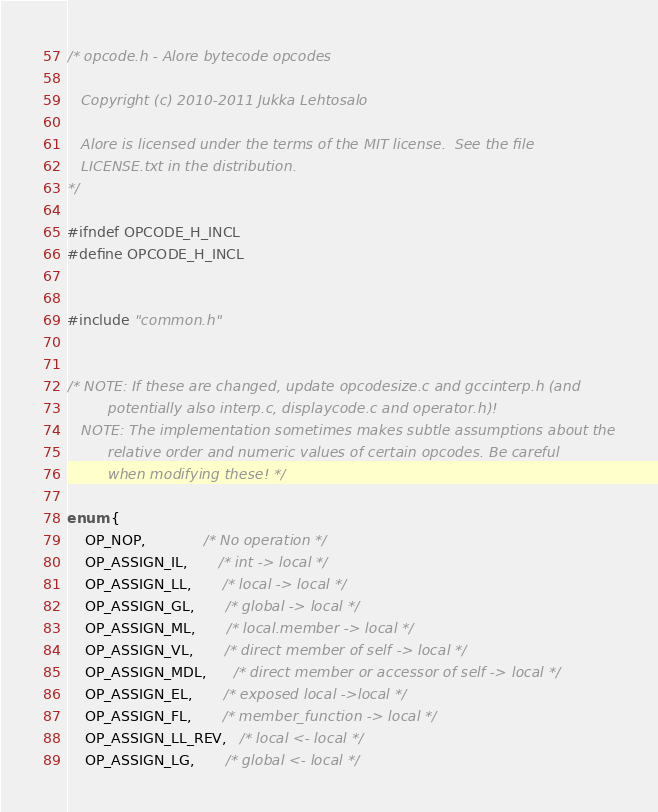Convert code to text. <code><loc_0><loc_0><loc_500><loc_500><_C_>/* opcode.h - Alore bytecode opcodes

   Copyright (c) 2010-2011 Jukka Lehtosalo

   Alore is licensed under the terms of the MIT license.  See the file
   LICENSE.txt in the distribution.
*/

#ifndef OPCODE_H_INCL
#define OPCODE_H_INCL


#include "common.h"


/* NOTE: If these are changed, update opcodesize.c and gccinterp.h (and
         potentially also interp.c, displaycode.c and operator.h)!
   NOTE: The implementation sometimes makes subtle assumptions about the
         relative order and numeric values of certain opcodes. Be careful
         when modifying these! */

enum {
    OP_NOP,             /* No operation */
    OP_ASSIGN_IL,       /* int -> local */
    OP_ASSIGN_LL,       /* local -> local */
    OP_ASSIGN_GL,       /* global -> local */
    OP_ASSIGN_ML,       /* local.member -> local */
    OP_ASSIGN_VL,       /* direct member of self -> local */
    OP_ASSIGN_MDL,      /* direct member or accessor of self -> local */
    OP_ASSIGN_EL,       /* exposed local ->local */
    OP_ASSIGN_FL,       /* member_function -> local */
    OP_ASSIGN_LL_REV,   /* local <- local */
    OP_ASSIGN_LG,       /* global <- local */</code> 